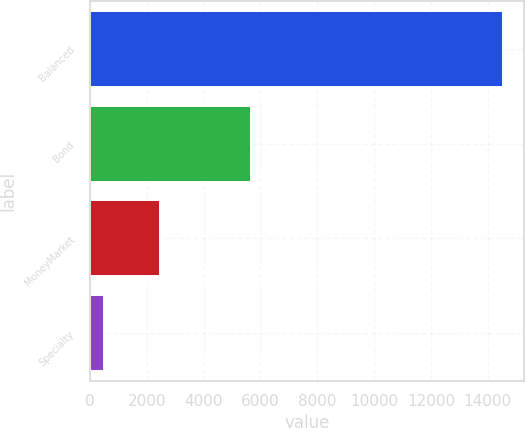<chart> <loc_0><loc_0><loc_500><loc_500><bar_chart><fcel>Balanced<fcel>Bond<fcel>MoneyMarket<fcel>Specialty<nl><fcel>14548<fcel>5671<fcel>2456<fcel>488<nl></chart> 